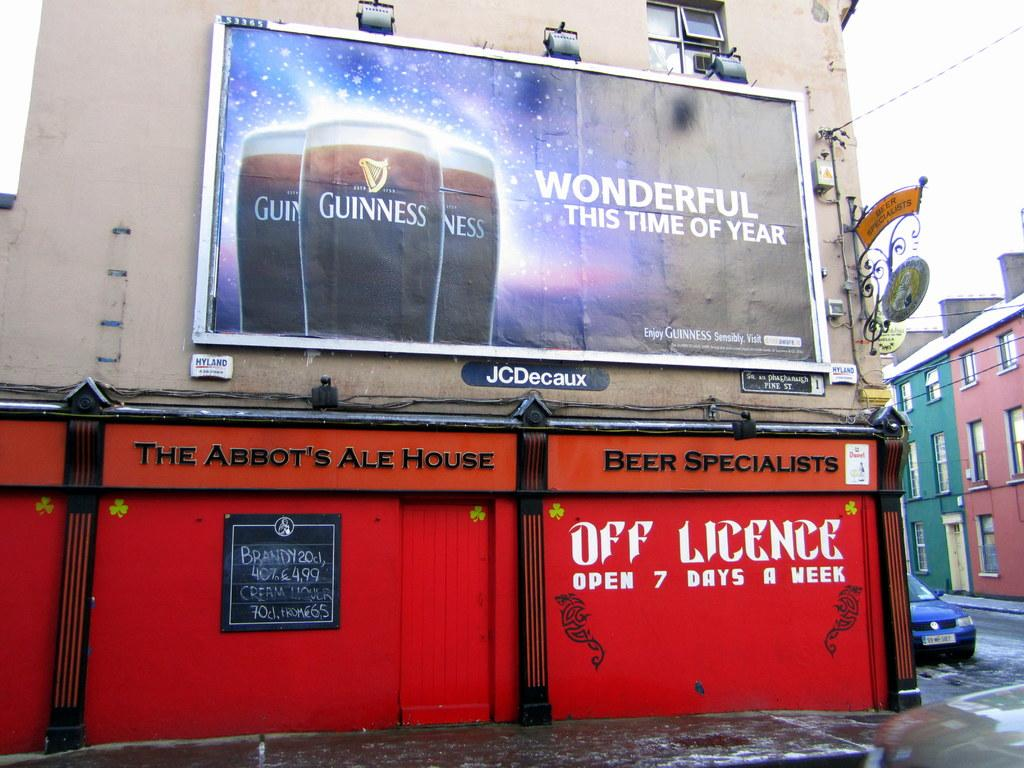<image>
Offer a succinct explanation of the picture presented. A large outdoor billboard for Guiness with images of beer on it. 